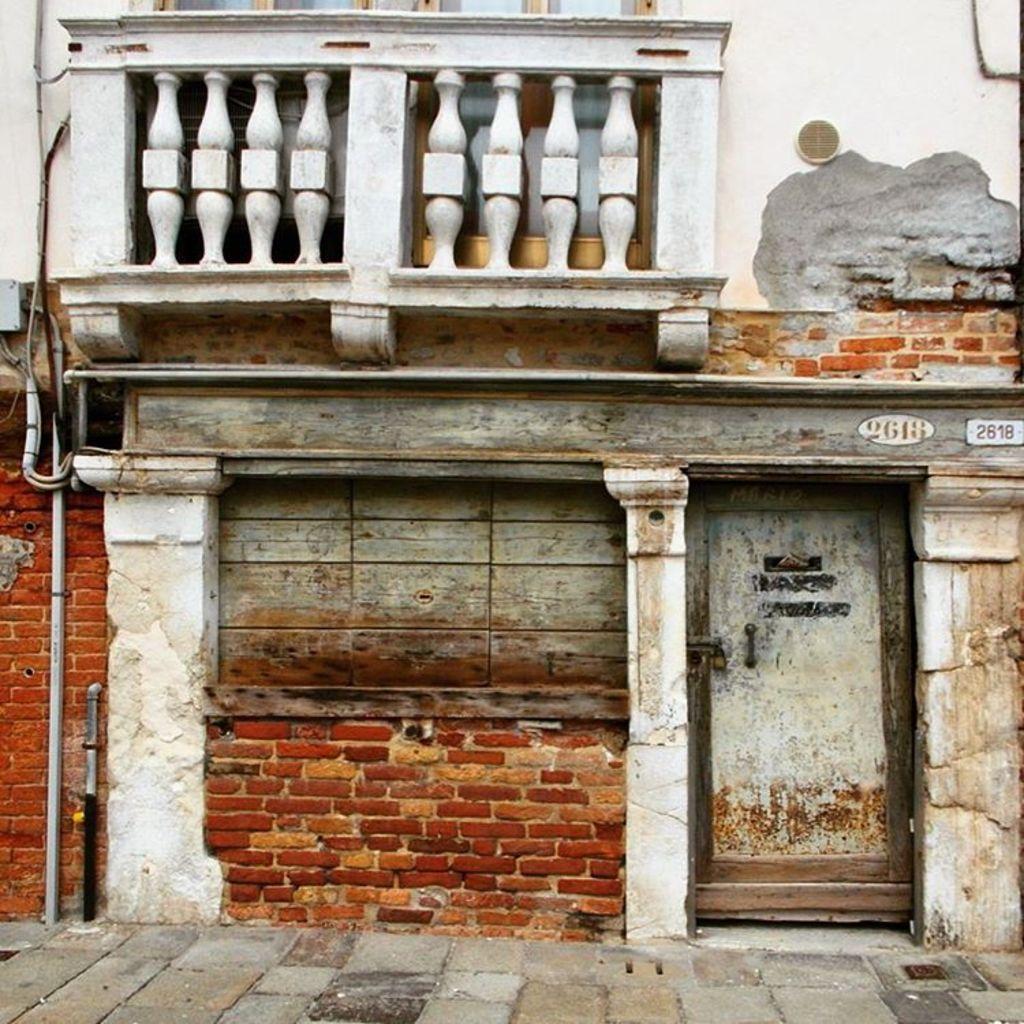Can you describe this image briefly? In this picture I can see a building and I can see a door on the right side of this image. I can also see numbers written on the building and I can see the path in front. 